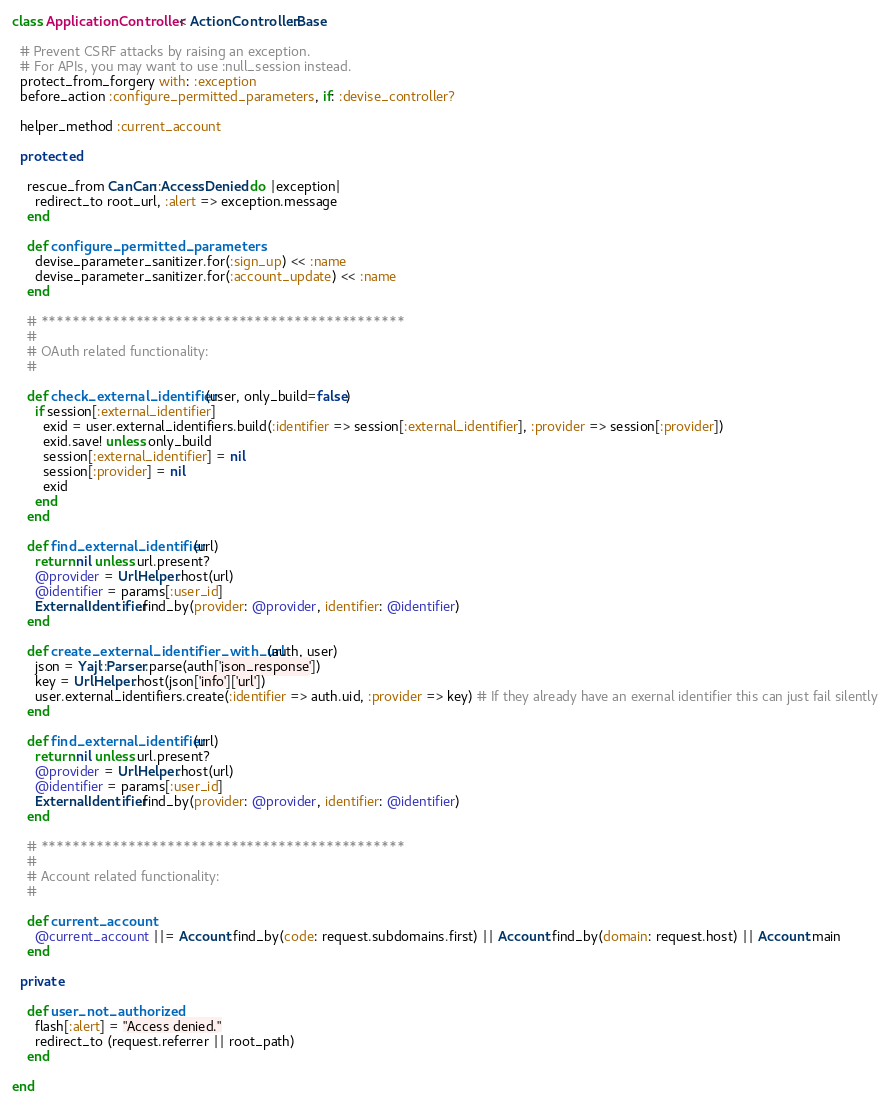<code> <loc_0><loc_0><loc_500><loc_500><_Ruby_>class ApplicationController < ActionController::Base

  # Prevent CSRF attacks by raising an exception.
  # For APIs, you may want to use :null_session instead.
  protect_from_forgery with: :exception
  before_action :configure_permitted_parameters, if: :devise_controller?

  helper_method :current_account

  protected

    rescue_from CanCan::AccessDenied do |exception|
      redirect_to root_url, :alert => exception.message
    end

    def configure_permitted_parameters
      devise_parameter_sanitizer.for(:sign_up) << :name
      devise_parameter_sanitizer.for(:account_update) << :name
    end

    # **********************************************
    #
    # OAuth related functionality:
    #

    def check_external_identifier(user, only_build=false)
      if session[:external_identifier]
        exid = user.external_identifiers.build(:identifier => session[:external_identifier], :provider => session[:provider])
        exid.save! unless only_build
        session[:external_identifier] = nil
        session[:provider] = nil
        exid
      end
    end

    def find_external_identifier(url)
      return nil unless url.present?
      @provider = UrlHelper.host(url)
      @identifier = params[:user_id]
      ExternalIdentifier.find_by(provider: @provider, identifier: @identifier)
    end

    def create_external_identifier_with_url(auth, user)
      json = Yajl::Parser.parse(auth['json_response'])
      key = UrlHelper.host(json['info']['url'])
      user.external_identifiers.create(:identifier => auth.uid, :provider => key) # If they already have an exernal identifier this can just fail silently
    end

    def find_external_identifier(url)
      return nil unless url.present?
      @provider = UrlHelper.host(url)
      @identifier = params[:user_id]
      ExternalIdentifier.find_by(provider: @provider, identifier: @identifier)
    end

    # **********************************************
    #
    # Account related functionality:
    #

    def current_account
      @current_account ||= Account.find_by(code: request.subdomains.first) || Account.find_by(domain: request.host) || Account.main
    end

  private

    def user_not_authorized
      flash[:alert] = "Access denied."
      redirect_to (request.referrer || root_path)
    end

end
</code> 